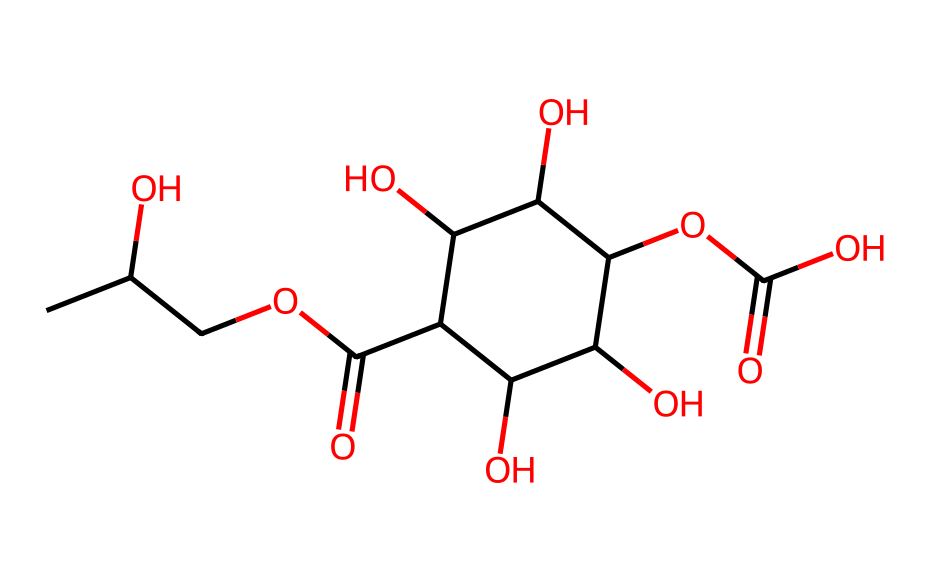What is the main functional group in propylene glycol alginate? The structure has multiple hydroxyl (-OH) groups, which are indicative of alcohol functional groups. These groups are crucial for the chemical's properties as a thickening agent.
Answer: hydroxyl How many carbon atoms are present in propylene glycol alginate? By inspecting the chemical structure, we count a total of 11 carbon atoms, which can be confirmed by following each branching and chain in the structure.
Answer: eleven What is the molecular formula corresponding to the given SMILES? When interpreting the SMILES representation, we can deduce the chemical composition, leading to the formula C11H20O10.
Answer: C11H20O10 Which part of the structure contributes to its viscosity when used as a thickening agent? The presence of multiple hydroxyl groups throughout the structure allows for extensive hydrogen bonding, leading to increased viscosity in solutions.
Answer: hydroxyl groups Is propylene glycol alginate soluble in water? Based on its chemical structure, the high number of polar hydroxyl groups suggests that it has good solubility in water due to strong hydrogen bonding capabilities.
Answer: soluble What kind of polymer is propylene glycol alginate classified as? Analyzing the structure, we see that it contains repetitive units linked by glycosidic bonds, adhering to the characteristics of polysaccharides.
Answer: polysaccharide 